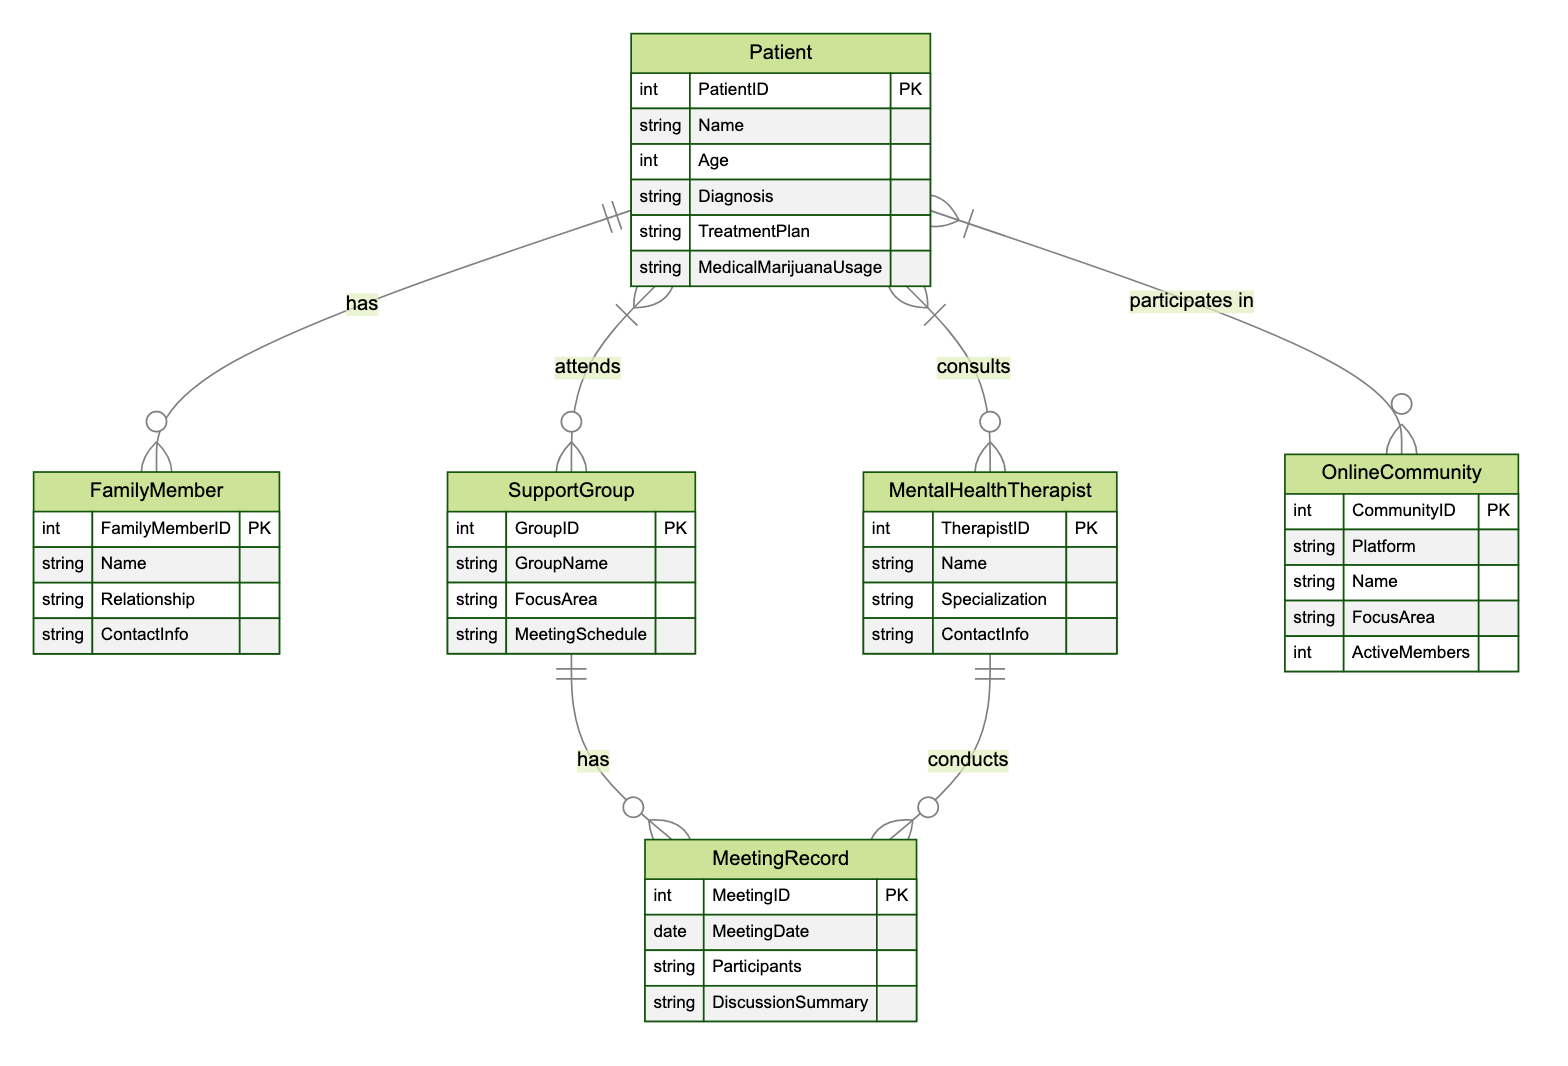What is the primary relationship between Patient and Family Member? The diagram shows a "One to Many" relationship between the Patient and Family Member entities, indicating that one patient can have multiple family members.
Answer: One to Many How many unique types of communication methods are represented in the diagram? Analyzing the relationships, we see connections between Patients and Support Groups, Mental Health Therapists, Family Members, and Online Communities, which totals four unique types of communication methods.
Answer: Four What identifies a Support Group in the diagram? Each Support Group is identified by the GroupID attribute, which serves as its primary key in the SupportGroup entity.
Answer: GroupID What relationship exists between Support Group and Meeting Record? The diagram indicates a "One to Many" relationship between Support Group and Meeting Record, meaning each support group can have multiple meeting records associated with it.
Answer: One to Many How many entities are involved in the relationships with the Patient? The relationships involving the Patient connect it to four different entities: Support Group, Mental Health Therapist, Family Member, and Online Community, resulting in four entities in total.
Answer: Four What does the Mental Health Therapist entity require? The Mental Health Therapist entity includes several attributes, one of which is the TherapistID, functioning as the primary key identifier for therapists in this entity.
Answer: TherapistID Can a Patient attend multiple Support Groups? Yes, the "Many to Many" relationship between Patient and Support Group indicates that a patient can attend multiple support groups.
Answer: Yes How is the Meeting Record associated with Mental Health Therapists? The Meeting Record has a "One to Many" relationship with Mental Health Therapists, which means that one therapist can conduct multiple meeting records.
Answer: One to Many 